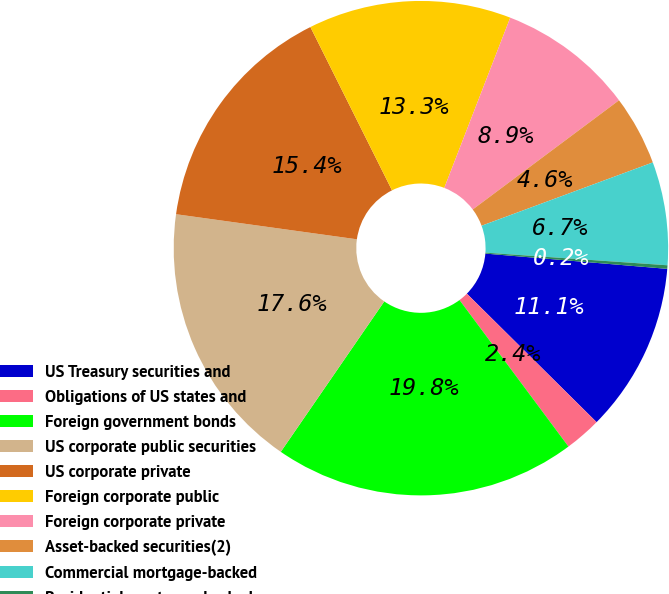Convert chart. <chart><loc_0><loc_0><loc_500><loc_500><pie_chart><fcel>US Treasury securities and<fcel>Obligations of US states and<fcel>Foreign government bonds<fcel>US corporate public securities<fcel>US corporate private<fcel>Foreign corporate public<fcel>Foreign corporate private<fcel>Asset-backed securities(2)<fcel>Commercial mortgage-backed<fcel>Residential mortgage-backed<nl><fcel>11.09%<fcel>2.4%<fcel>19.77%<fcel>17.6%<fcel>15.43%<fcel>13.26%<fcel>8.91%<fcel>4.57%<fcel>6.74%<fcel>0.23%<nl></chart> 